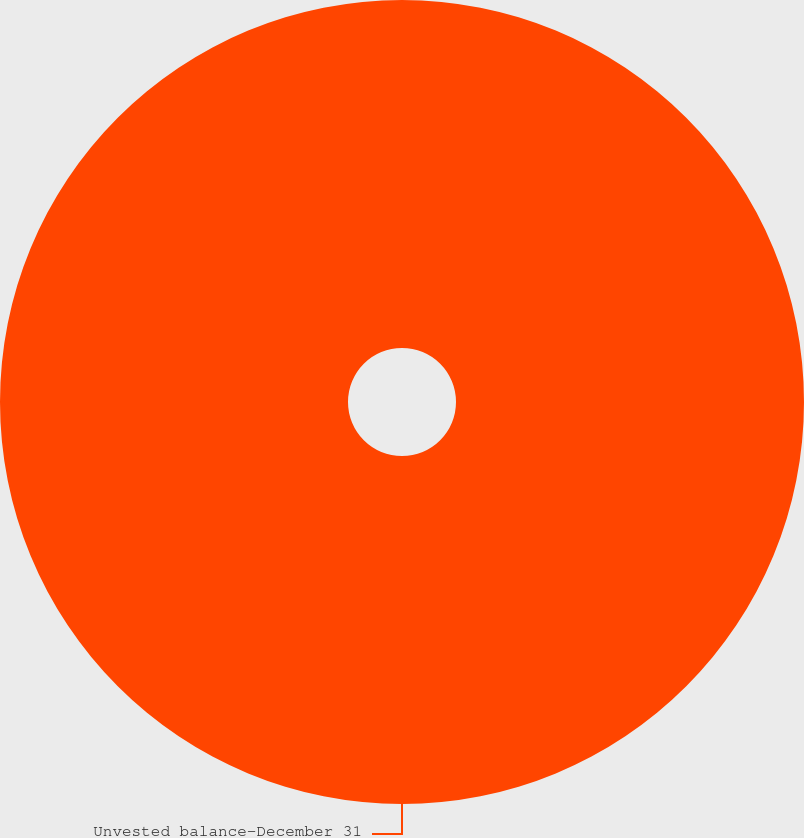Convert chart. <chart><loc_0><loc_0><loc_500><loc_500><pie_chart><fcel>Unvested balance-December 31<nl><fcel>100.0%<nl></chart> 